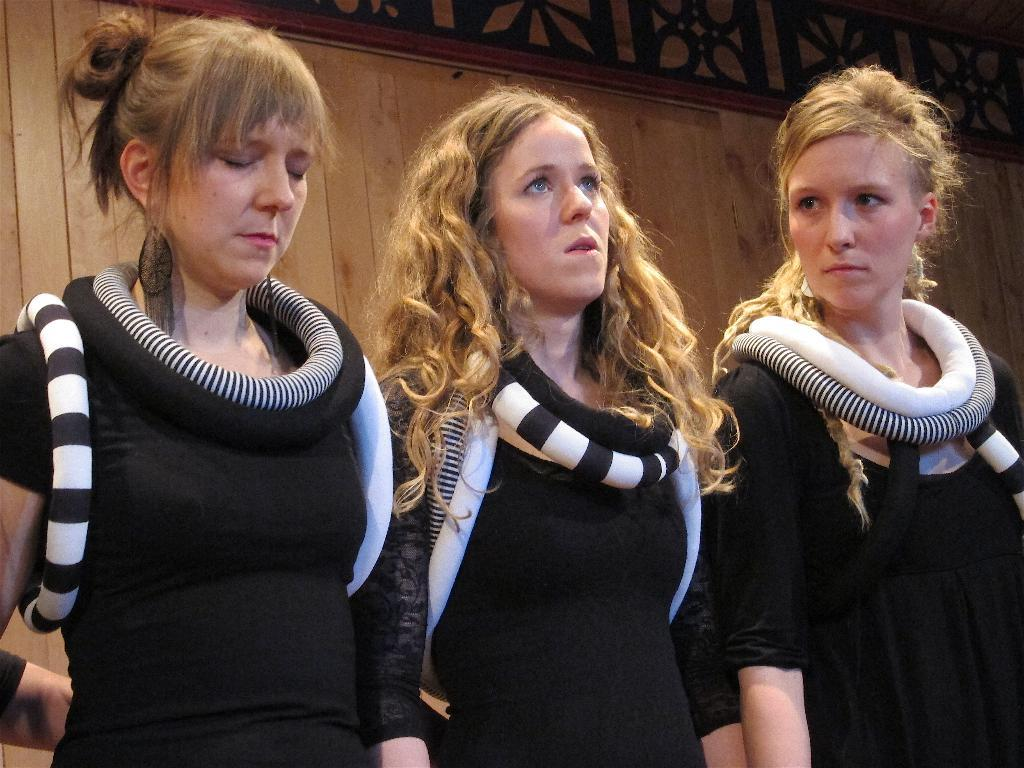How many people are in the image? There are three persons in the image. What are the people wearing? The persons are wearing black and white costumes. What are the people doing in the image? The persons are standing. What can be seen in the background of the image? There is a wooden wall in the background of the image. What type of afterthought can be seen on the wooden wall in the image? There is no afterthought present on the wooden wall in the image. What sound does the zipper make when the persons are adjusting their costumes in the image? There are no zippers or sounds mentioned in the image; the persons are wearing costumes, but no specific details about the costumes are provided. 